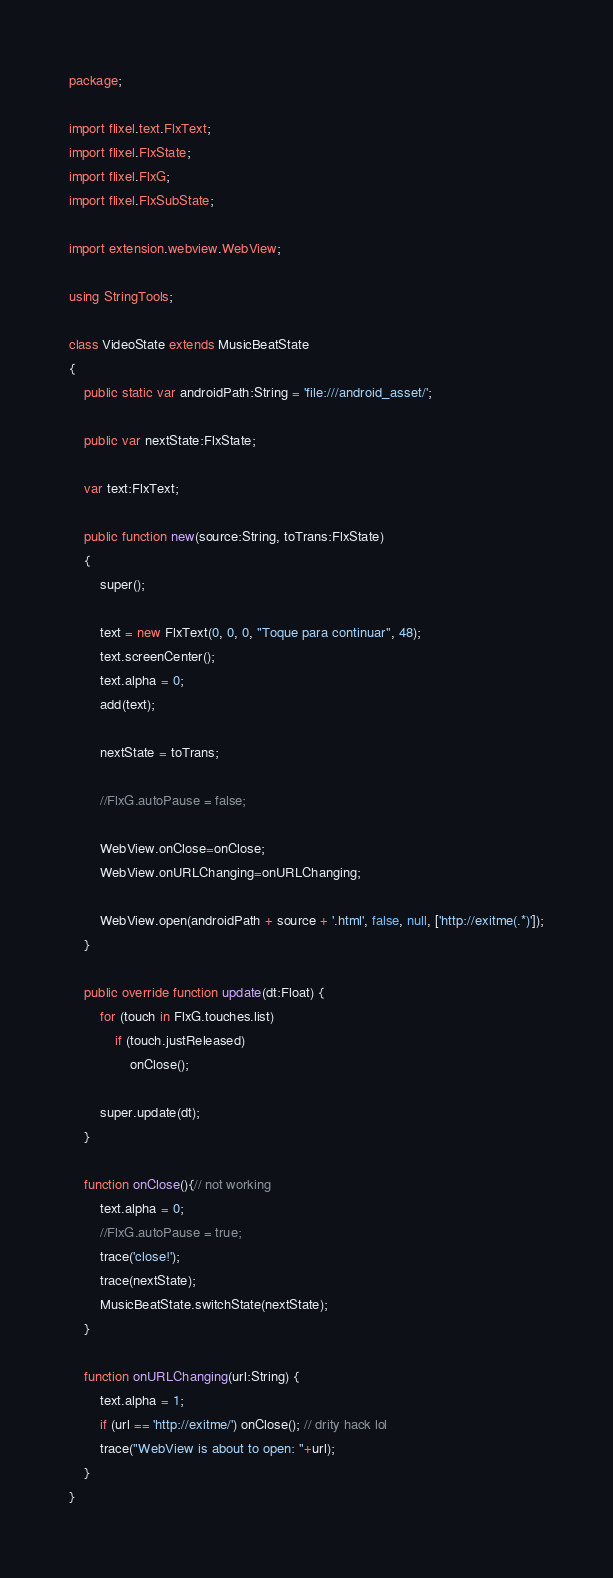<code> <loc_0><loc_0><loc_500><loc_500><_Haxe_>package;

import flixel.text.FlxText;
import flixel.FlxState;
import flixel.FlxG;
import flixel.FlxSubState;

import extension.webview.WebView;

using StringTools;

class VideoState extends MusicBeatState
{
	public static var androidPath:String = 'file:///android_asset/';

	public var nextState:FlxState;

	var text:FlxText;

	public function new(source:String, toTrans:FlxState)
	{
		super();

		text = new FlxText(0, 0, 0, "Toque para continuar", 48);
		text.screenCenter();
		text.alpha = 0;
		add(text);

		nextState = toTrans;

		//FlxG.autoPause = false;

		WebView.onClose=onClose;
		WebView.onURLChanging=onURLChanging;

		WebView.open(androidPath + source + '.html', false, null, ['http://exitme(.*)']);
	}

	public override function update(dt:Float) {
		for (touch in FlxG.touches.list)
			if (touch.justReleased)
				onClose();

		super.update(dt);	
	}

	function onClose(){// not working
		text.alpha = 0;
		//FlxG.autoPause = true;
		trace('close!');
		trace(nextState);
		MusicBeatState.switchState(nextState);
	}

	function onURLChanging(url:String) {
		text.alpha = 1;
		if (url == 'http://exitme/') onClose(); // drity hack lol
		trace("WebView is about to open: "+url);
	}
}</code> 